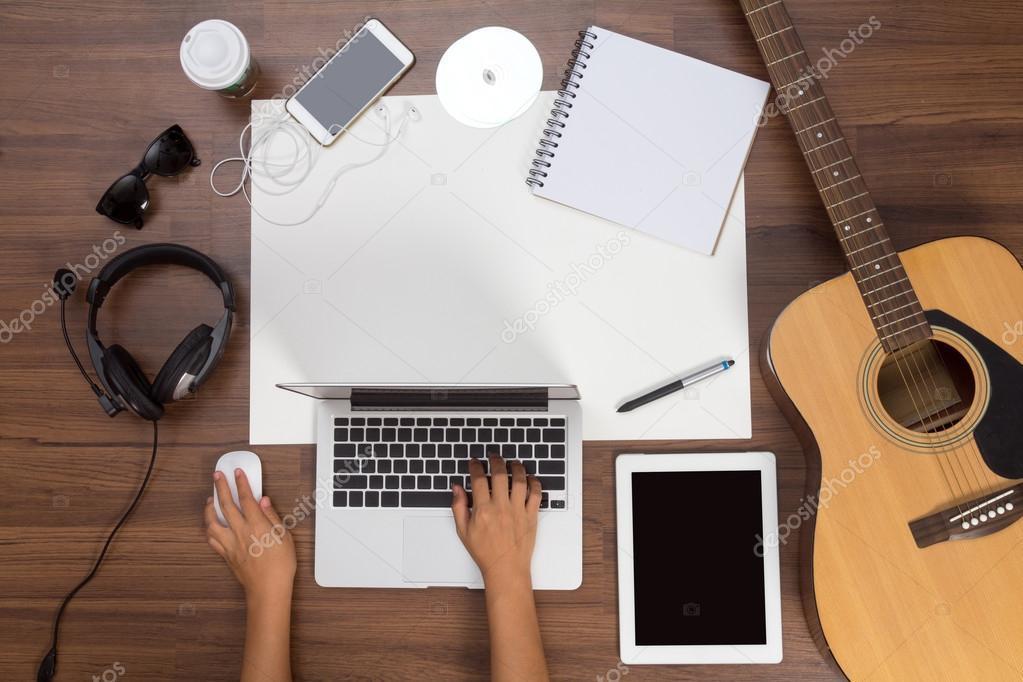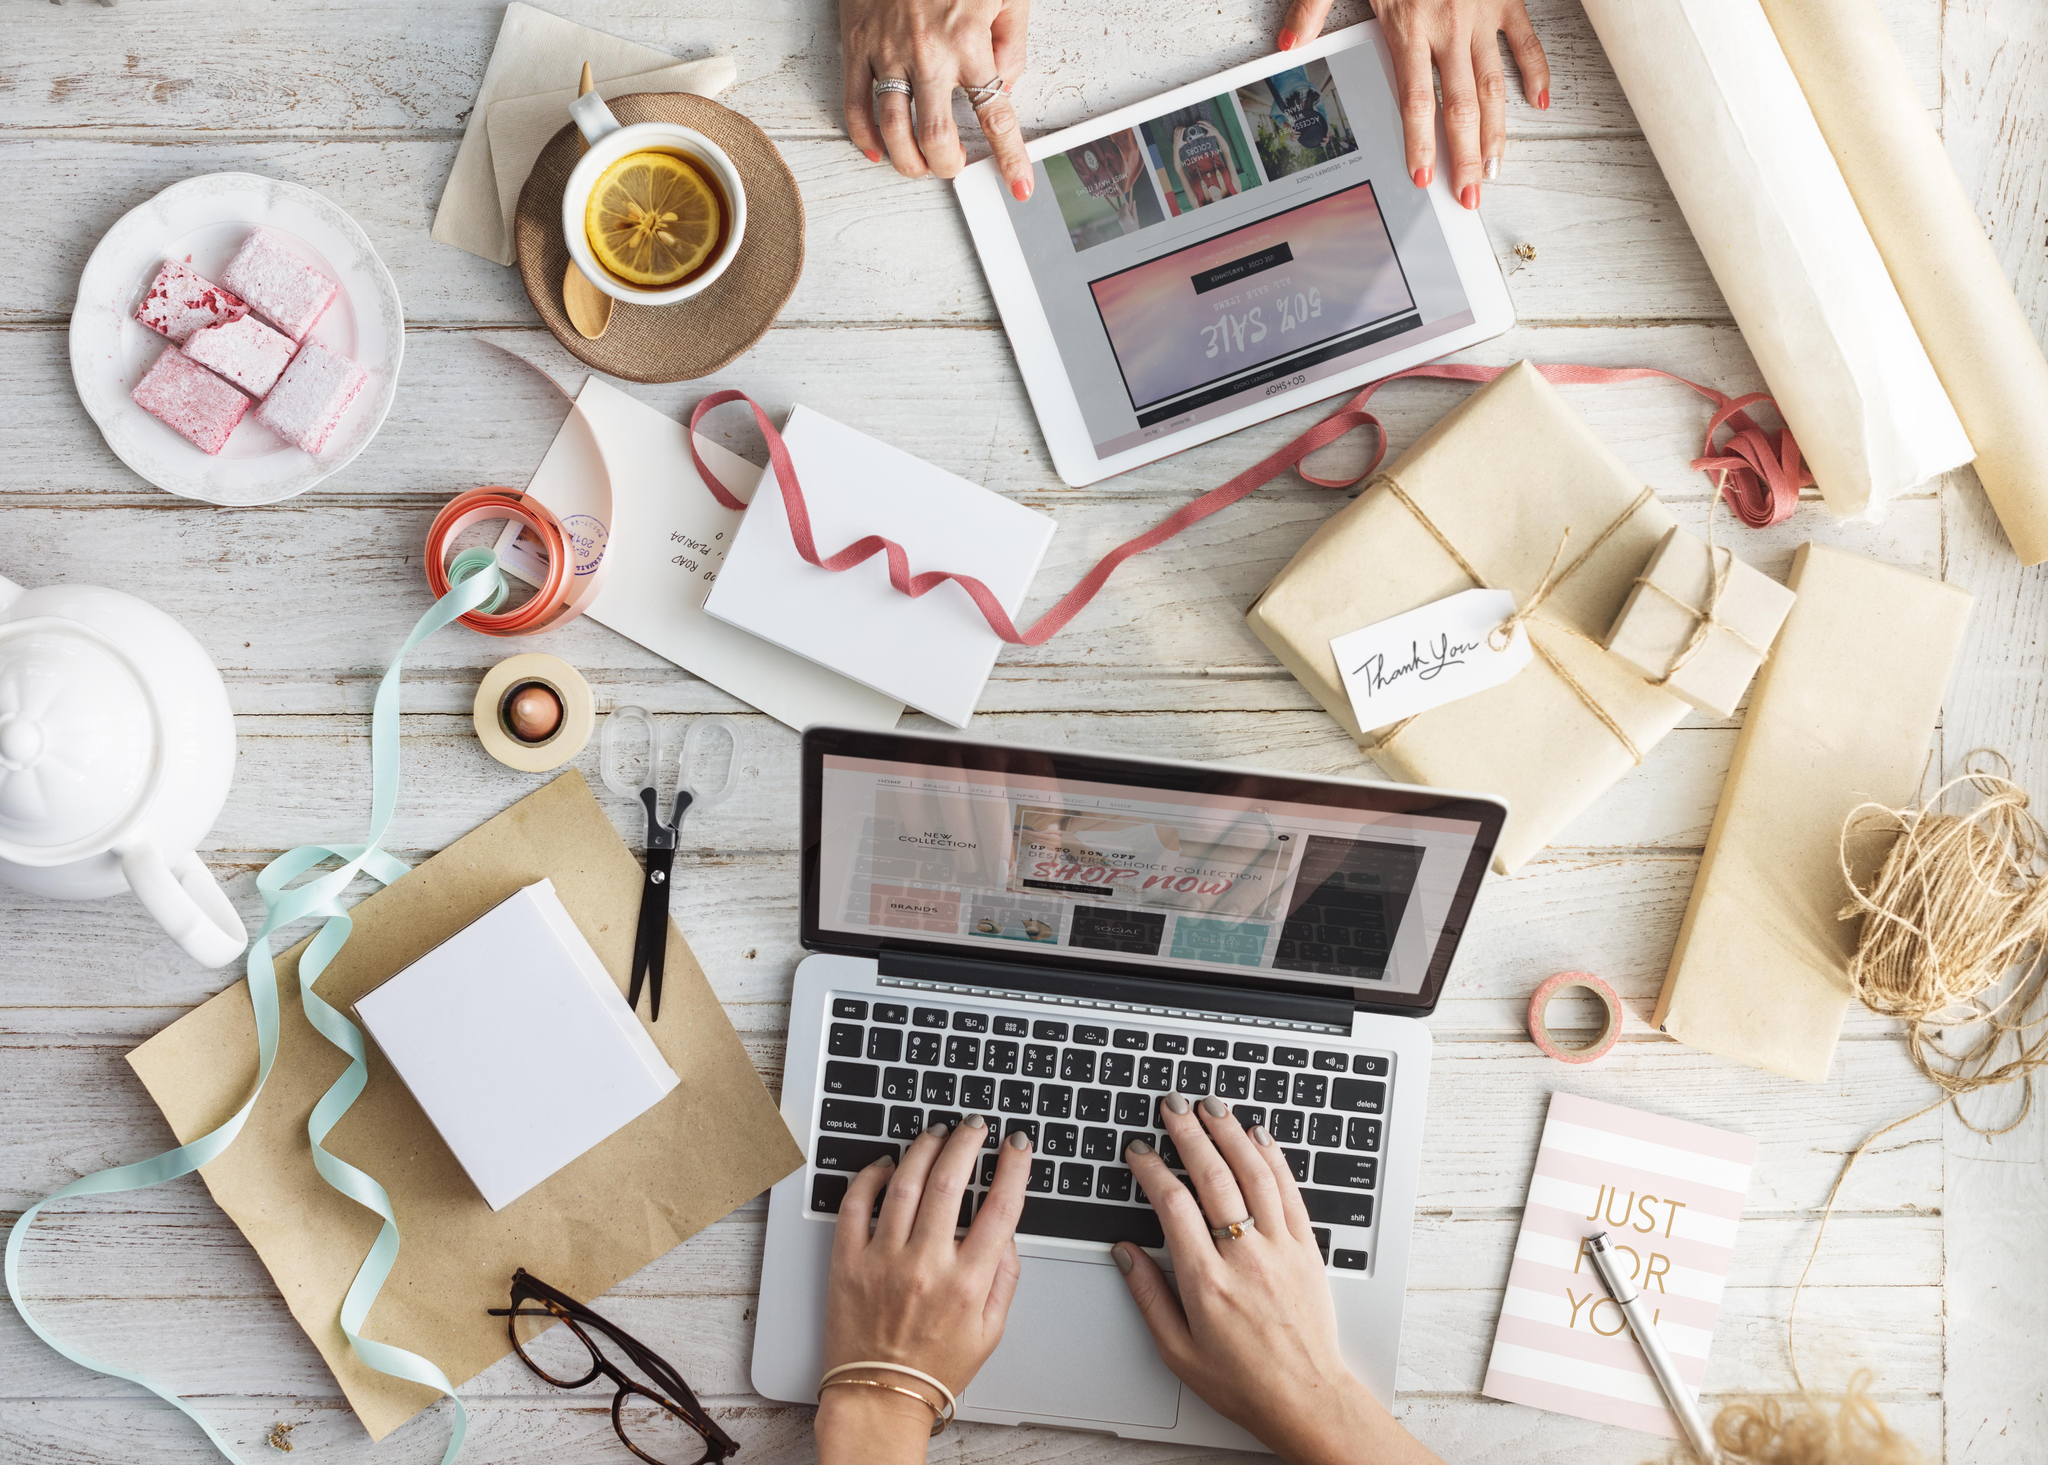The first image is the image on the left, the second image is the image on the right. Assess this claim about the two images: "A pen is on a paper near a laptop in at least one of the images.". Correct or not? Answer yes or no. Yes. The first image is the image on the left, the second image is the image on the right. Considering the images on both sides, is "Each image shows at least one hand on the keyboard of a laptop with its open screen facing leftward." valid? Answer yes or no. No. 